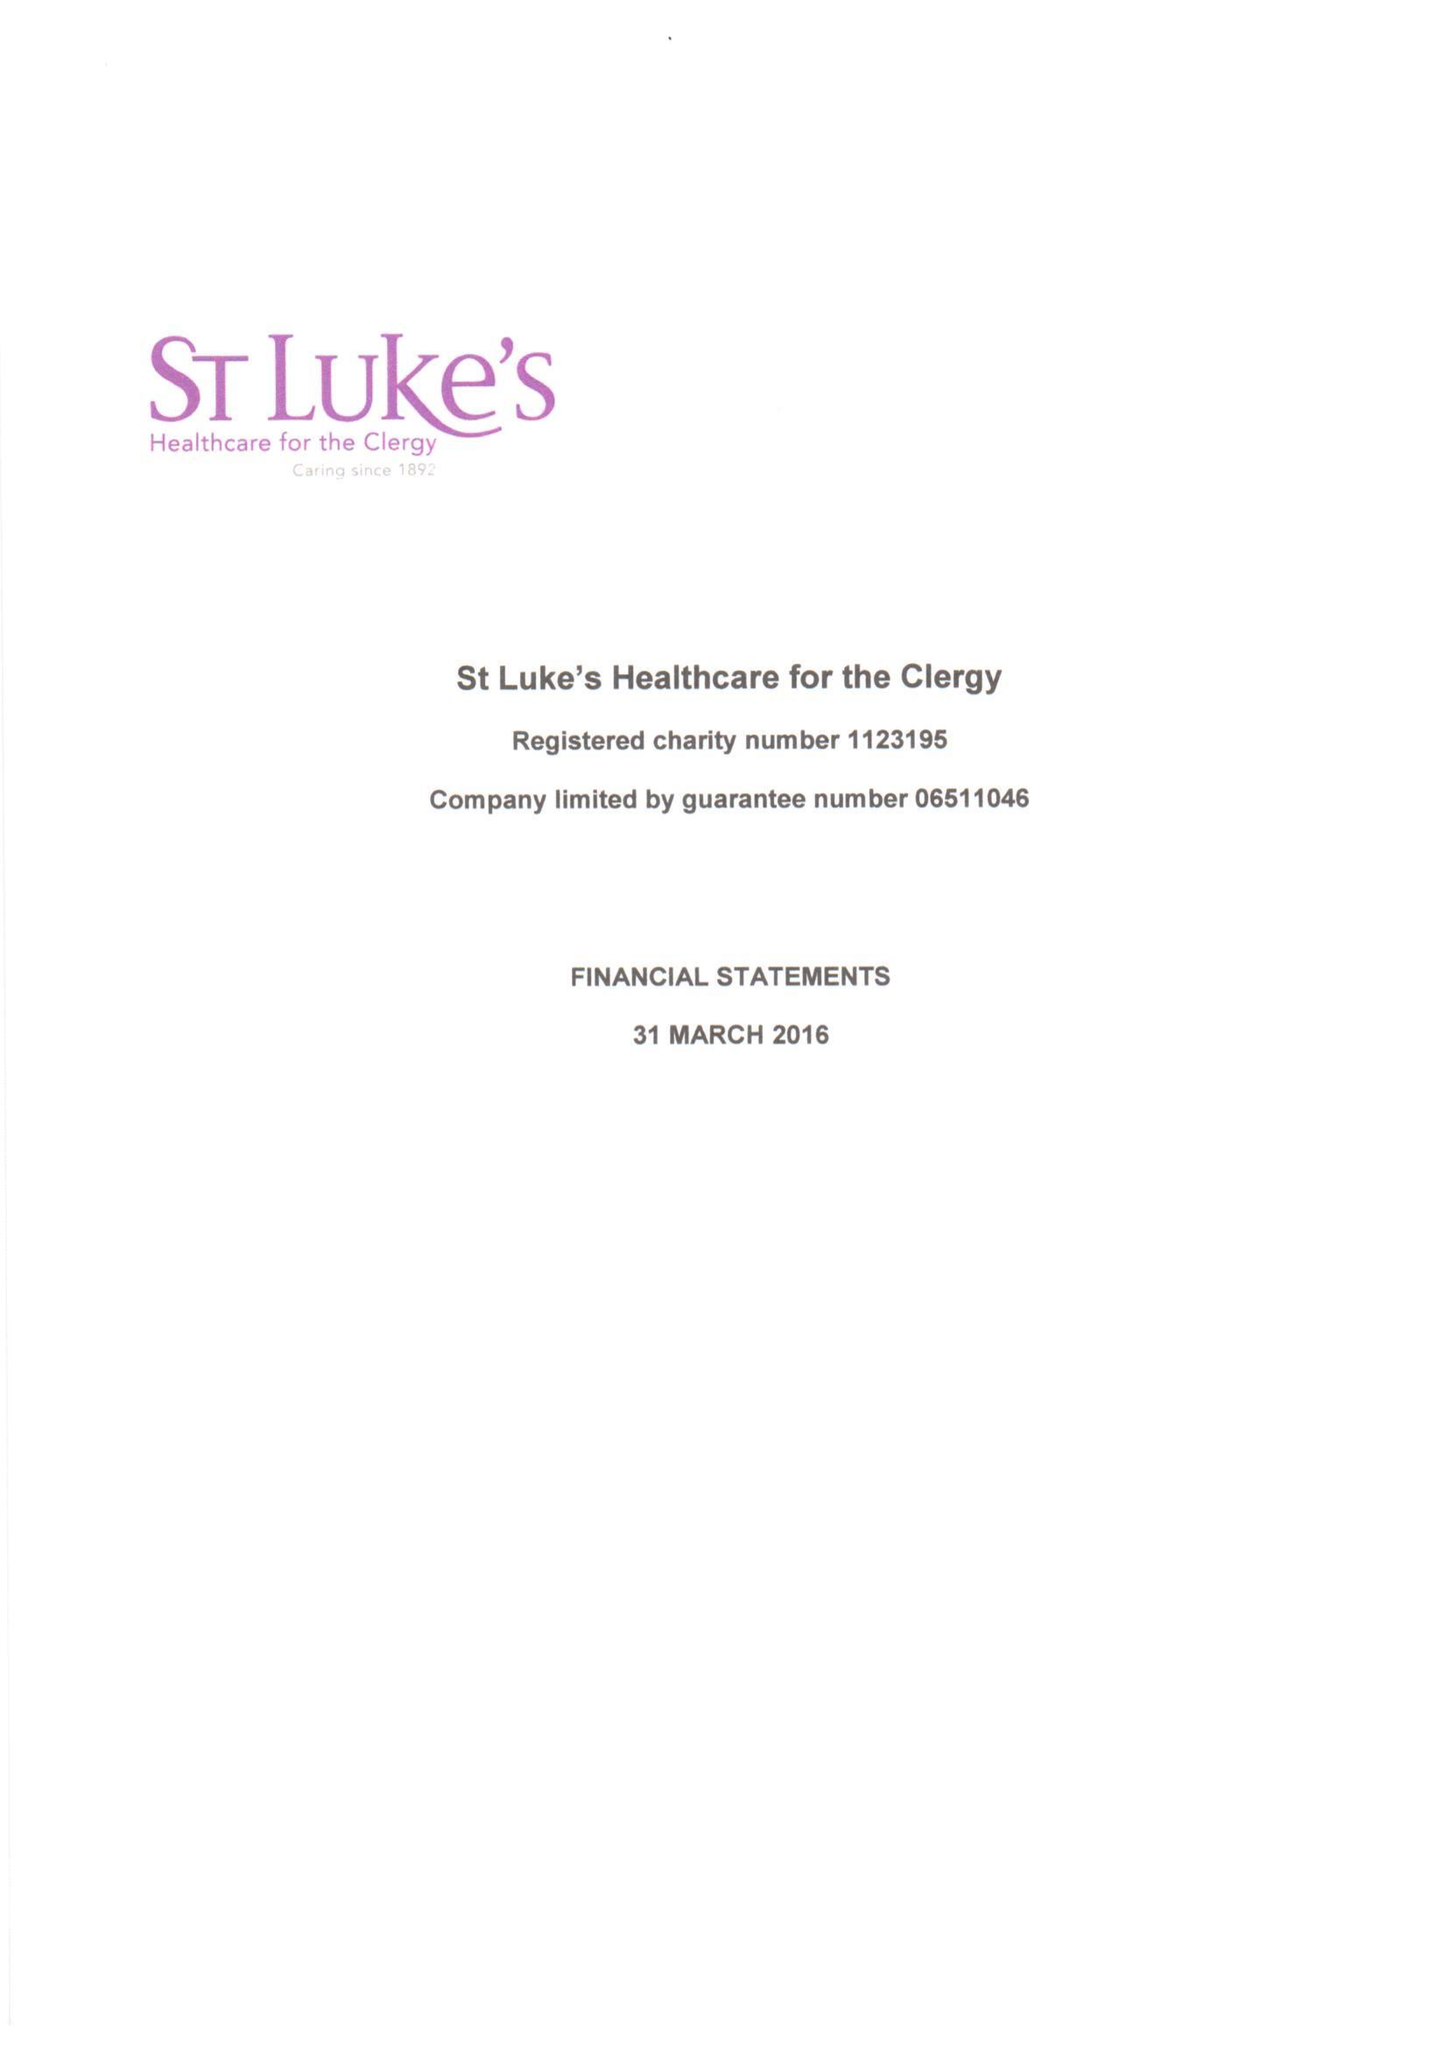What is the value for the charity_number?
Answer the question using a single word or phrase. 1123195 